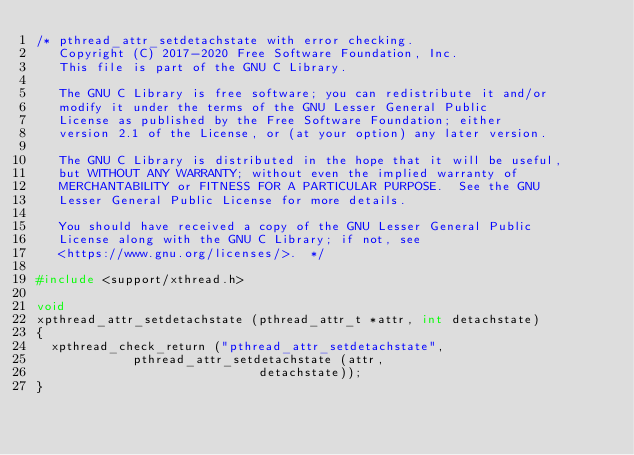<code> <loc_0><loc_0><loc_500><loc_500><_C_>/* pthread_attr_setdetachstate with error checking.
   Copyright (C) 2017-2020 Free Software Foundation, Inc.
   This file is part of the GNU C Library.

   The GNU C Library is free software; you can redistribute it and/or
   modify it under the terms of the GNU Lesser General Public
   License as published by the Free Software Foundation; either
   version 2.1 of the License, or (at your option) any later version.

   The GNU C Library is distributed in the hope that it will be useful,
   but WITHOUT ANY WARRANTY; without even the implied warranty of
   MERCHANTABILITY or FITNESS FOR A PARTICULAR PURPOSE.  See the GNU
   Lesser General Public License for more details.

   You should have received a copy of the GNU Lesser General Public
   License along with the GNU C Library; if not, see
   <https://www.gnu.org/licenses/>.  */

#include <support/xthread.h>

void
xpthread_attr_setdetachstate (pthread_attr_t *attr, int detachstate)
{
  xpthread_check_return ("pthread_attr_setdetachstate",
			 pthread_attr_setdetachstate (attr,
						      detachstate));
}
</code> 